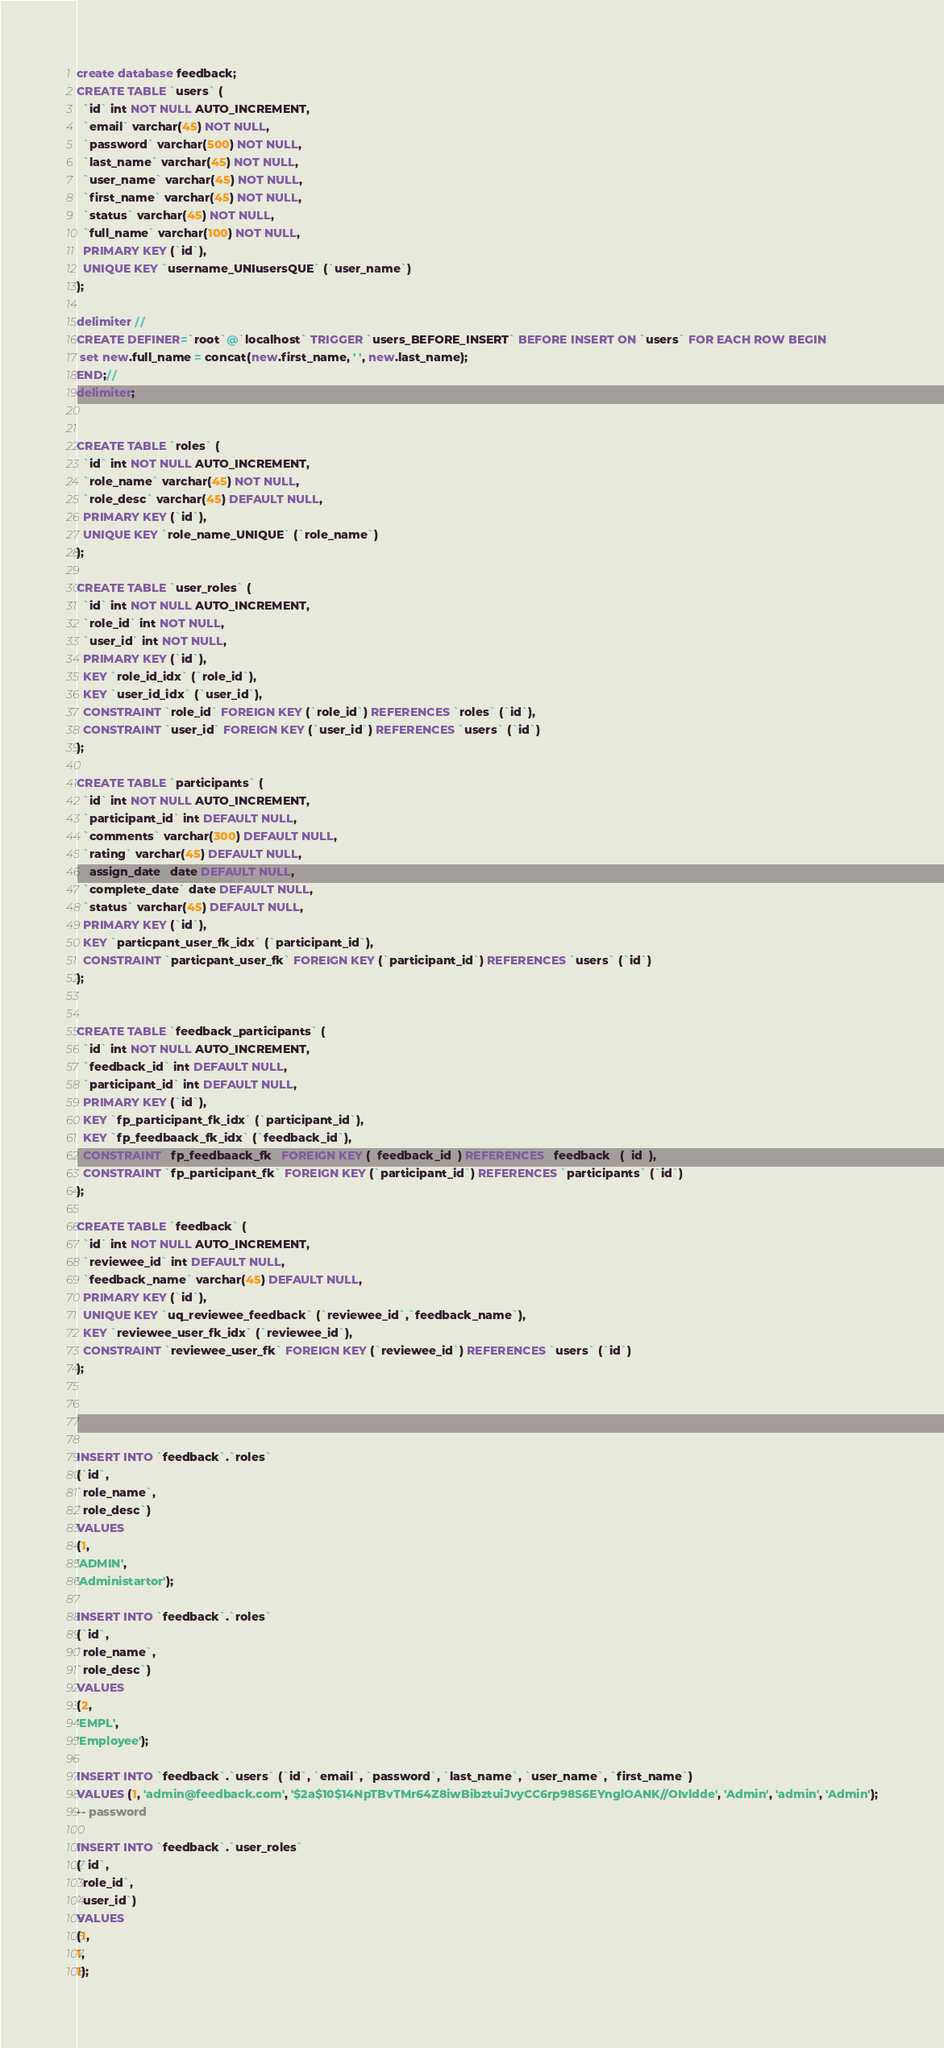Convert code to text. <code><loc_0><loc_0><loc_500><loc_500><_SQL_>create database feedback;
CREATE TABLE `users` (
  `id` int NOT NULL AUTO_INCREMENT,
  `email` varchar(45) NOT NULL,
  `password` varchar(500) NOT NULL,
  `last_name` varchar(45) NOT NULL,
  `user_name` varchar(45) NOT NULL,
  `first_name` varchar(45) NOT NULL,
  `status` varchar(45) NOT NULL,
  `full_name` varchar(100) NOT NULL,
  PRIMARY KEY (`id`),
  UNIQUE KEY `username_UNIusersQUE` (`user_name`)
);

delimiter //
CREATE DEFINER=`root`@`localhost` TRIGGER `users_BEFORE_INSERT` BEFORE INSERT ON `users` FOR EACH ROW BEGIN
 set new.full_name = concat(new.first_name, ' ', new.last_name);
END;//
delimiter;


CREATE TABLE `roles` (
  `id` int NOT NULL AUTO_INCREMENT,
  `role_name` varchar(45) NOT NULL,
  `role_desc` varchar(45) DEFAULT NULL,
  PRIMARY KEY (`id`),
  UNIQUE KEY `role_name_UNIQUE` (`role_name`)
);

CREATE TABLE `user_roles` (
  `id` int NOT NULL AUTO_INCREMENT,
  `role_id` int NOT NULL,
  `user_id` int NOT NULL,
  PRIMARY KEY (`id`),
  KEY `role_id_idx` (`role_id`),
  KEY `user_id_idx` (`user_id`),
  CONSTRAINT `role_id` FOREIGN KEY (`role_id`) REFERENCES `roles` (`id`),
  CONSTRAINT `user_id` FOREIGN KEY (`user_id`) REFERENCES `users` (`id`)
);

CREATE TABLE `participants` (
  `id` int NOT NULL AUTO_INCREMENT,
  `participant_id` int DEFAULT NULL,
  `comments` varchar(300) DEFAULT NULL,
  `rating` varchar(45) DEFAULT NULL,
  `assign_date` date DEFAULT NULL,
  `complete_date` date DEFAULT NULL,
  `status` varchar(45) DEFAULT NULL,
  PRIMARY KEY (`id`),
  KEY `particpant_user_fk_idx` (`participant_id`),
  CONSTRAINT `particpant_user_fk` FOREIGN KEY (`participant_id`) REFERENCES `users` (`id`)
);


CREATE TABLE `feedback_participants` (
  `id` int NOT NULL AUTO_INCREMENT,
  `feedback_id` int DEFAULT NULL,
  `participant_id` int DEFAULT NULL,
  PRIMARY KEY (`id`),
  KEY `fp_participant_fk_idx` (`participant_id`),
  KEY `fp_feedbaack_fk_idx` (`feedback_id`),
  CONSTRAINT `fp_feedbaack_fk` FOREIGN KEY (`feedback_id`) REFERENCES `feedback` (`id`),
  CONSTRAINT `fp_participant_fk` FOREIGN KEY (`participant_id`) REFERENCES `participants` (`id`)
);

CREATE TABLE `feedback` (
  `id` int NOT NULL AUTO_INCREMENT,
  `reviewee_id` int DEFAULT NULL,
  `feedback_name` varchar(45) DEFAULT NULL,
  PRIMARY KEY (`id`),
  UNIQUE KEY `uq_reviewee_feedback` (`reviewee_id`,`feedback_name`),
  KEY `reviewee_user_fk_idx` (`reviewee_id`),
  CONSTRAINT `reviewee_user_fk` FOREIGN KEY (`reviewee_id`) REFERENCES `users` (`id`)
);




INSERT INTO `feedback`.`roles`
(`id`,
`role_name`,
`role_desc`)
VALUES
(1,
'ADMIN',
'Administartor');

INSERT INTO `feedback`.`roles`
(`id`,
`role_name`,
`role_desc`)
VALUES
(2,
'EMPL',
'Employee');

INSERT INTO `feedback`.`users` (`id`, `email`, `password`, `last_name`, `user_name`, `first_name`) 
VALUES (1, 'admin@feedback.com', '$2a$10$14NpTBvTMr64Z8iwBibztuiJvyCC6rp98S6EYnglOANK//OIvldde', 'Admin', 'admin', 'Admin');
-- password

INSERT INTO `feedback`.`user_roles`
(`id`,
`role_id`,
`user_id`)
VALUES
(1,
1,
1);
</code> 